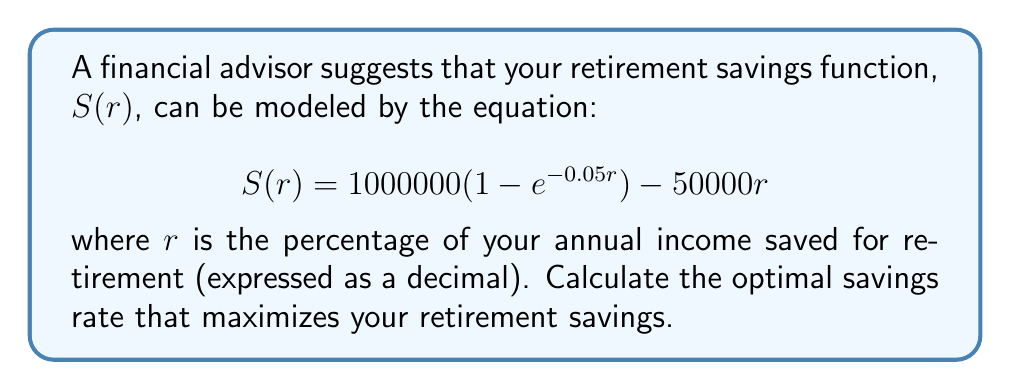Give your solution to this math problem. To find the optimal savings rate, we need to find the maximum of the function $S(r)$. This can be done by finding where the derivative of $S(r)$ equals zero.

1. First, let's find the derivative of $S(r)$:

   $$\frac{dS}{dr} = 1000000(0.05e^{-0.05r}) - 50000$$

2. Now, set the derivative equal to zero and solve for $r$:

   $$1000000(0.05e^{-0.05r}) - 50000 = 0$$
   $$50000e^{-0.05r} - 50000 = 0$$
   $$50000e^{-0.05r} = 50000$$
   $$e^{-0.05r} = 1$$
   $$-0.05r = \ln(1) = 0$$
   $$r = 0$$

3. To confirm this is a maximum (not a minimum), we can check the second derivative:

   $$\frac{d^2S}{dr^2} = 1000000(-0.05^2e^{-0.05r}) = -2500e^{-0.05r}$$

   At $r = 0$, this is negative, confirming a maximum.

4. However, since $r$ represents a savings rate, it must be non-negative. The fact that our critical point is at $r = 0$ suggests that the function is decreasing for all positive $r$.

5. To find the optimal positive savings rate, we need to consider the domain constraints. Typically, retirement savings rates are between 0% and 25% of annual income.

6. Evaluating $S(r)$ at the endpoints:
   
   At $r = 0$: $S(0) = 0$
   At $r = 0.25$: $S(0.25) \approx 224,790.56$

Therefore, within the typical range of retirement savings rates, the optimal rate is 25% (0.25 as a decimal) of annual income.
Answer: The optimal savings rate is 25% (0.25 as a decimal) of annual income. 